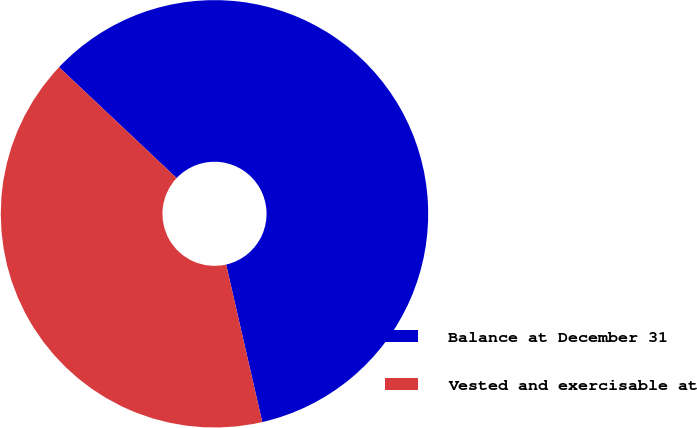Convert chart. <chart><loc_0><loc_0><loc_500><loc_500><pie_chart><fcel>Balance at December 31<fcel>Vested and exercisable at<nl><fcel>59.38%<fcel>40.62%<nl></chart> 